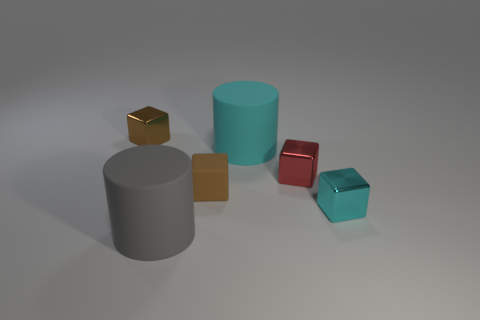Is there a brown object of the same size as the cyan block?
Ensure brevity in your answer.  Yes. What size is the brown thing that is the same material as the large gray cylinder?
Give a very brief answer. Small. What shape is the small matte thing?
Your response must be concise. Cube. Do the tiny red object and the large thing in front of the cyan cube have the same material?
Your answer should be compact. No. What number of things are tiny brown metallic blocks or tiny objects?
Offer a very short reply. 4. Are any brown things visible?
Your answer should be very brief. Yes. There is a brown object in front of the brown object behind the red shiny block; what shape is it?
Give a very brief answer. Cube. How many objects are either big matte things to the right of the large gray matte object or things that are right of the tiny matte thing?
Make the answer very short. 3. There is a cyan block that is the same size as the red metallic block; what is its material?
Your response must be concise. Metal. The tiny rubber object is what color?
Your answer should be compact. Brown. 